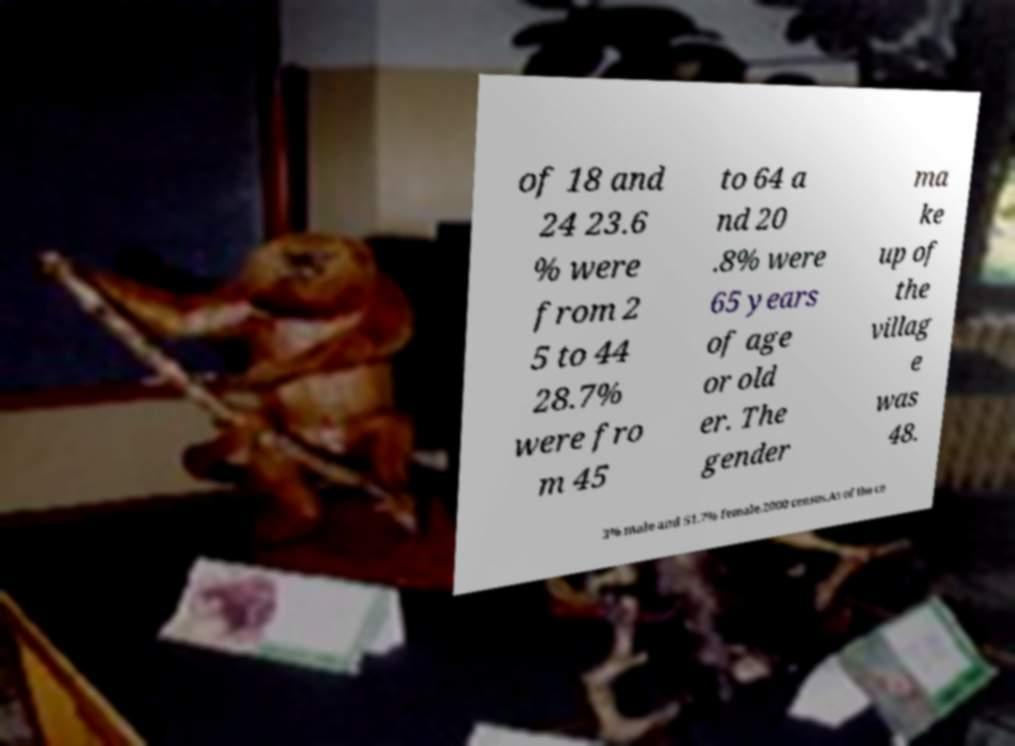There's text embedded in this image that I need extracted. Can you transcribe it verbatim? of 18 and 24 23.6 % were from 2 5 to 44 28.7% were fro m 45 to 64 a nd 20 .8% were 65 years of age or old er. The gender ma ke up of the villag e was 48. 3% male and 51.7% female.2000 census.As of the ce 